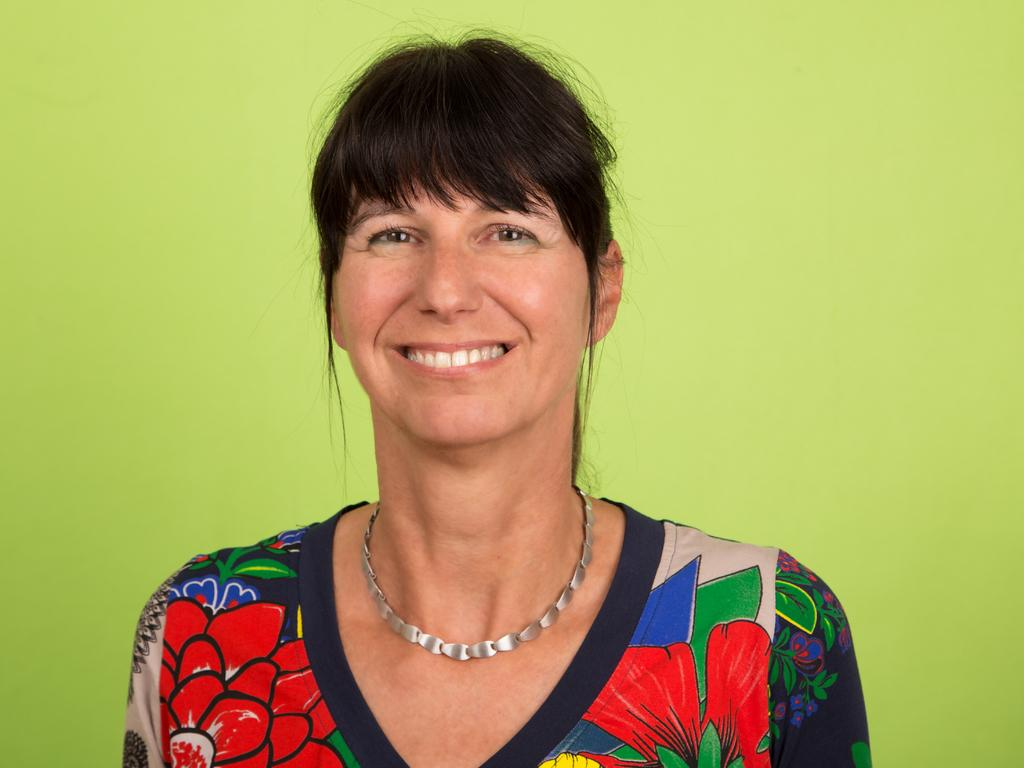Who is present in the image? There is a woman in the image. What is the woman wearing? The woman is wearing clothes and a neck chain. What is the woman's facial expression? The woman is smiling. What is the background color in the image? The background color is parrot green. What type of force is being applied to the woman in the image? There is no force being applied to the woman in the image; she is standing still and smiling. What credit card is the woman using in the image? There is no credit card or any financial transaction depicted in the image. 